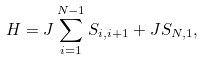Convert formula to latex. <formula><loc_0><loc_0><loc_500><loc_500>H = J \sum _ { i = 1 } ^ { N - 1 } S _ { i , i + 1 } + J S _ { N , 1 } ,</formula> 